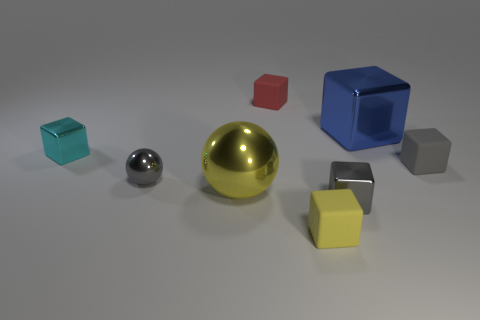There is a small rubber thing that is the same color as the large sphere; what is its shape?
Provide a succinct answer. Cube. Is the number of small gray things that are left of the small gray rubber thing less than the number of red objects that are behind the yellow sphere?
Offer a very short reply. No. There is a gray thing that is behind the gray object that is on the left side of the large yellow shiny thing; what number of yellow things are behind it?
Ensure brevity in your answer.  0. The other shiny thing that is the same shape as the large yellow object is what size?
Offer a terse response. Small. Is there any other thing that has the same size as the gray matte cube?
Ensure brevity in your answer.  Yes. Is the number of red matte cubes that are to the left of the small gray shiny cube less than the number of red metal things?
Make the answer very short. No. Is the gray rubber thing the same shape as the blue object?
Give a very brief answer. Yes. What is the color of the other big object that is the same shape as the yellow matte object?
Ensure brevity in your answer.  Blue. What number of small matte blocks are the same color as the tiny shiny ball?
Provide a succinct answer. 1. How many things are tiny blocks that are behind the yellow metal ball or gray shiny spheres?
Provide a succinct answer. 4. 